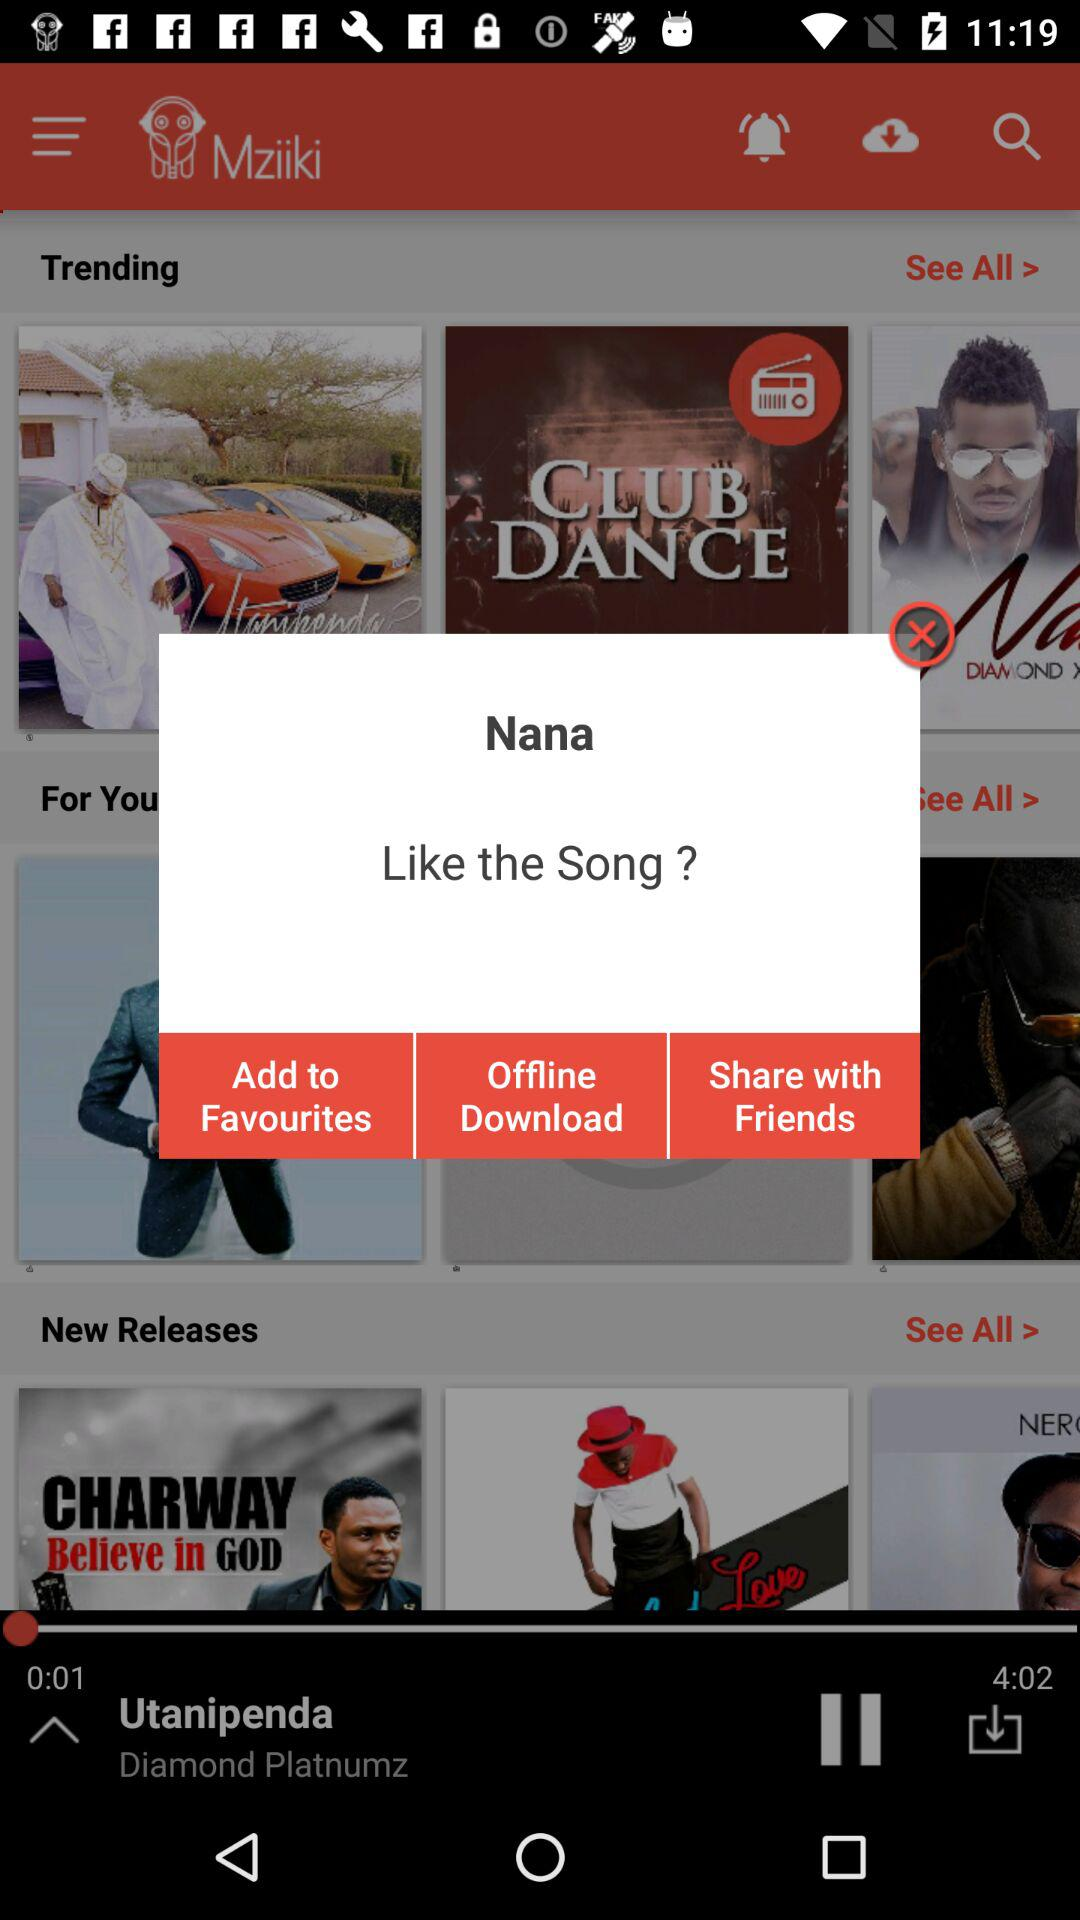What is the name of the song that is playing? The name of the song is "Utanipenda". 